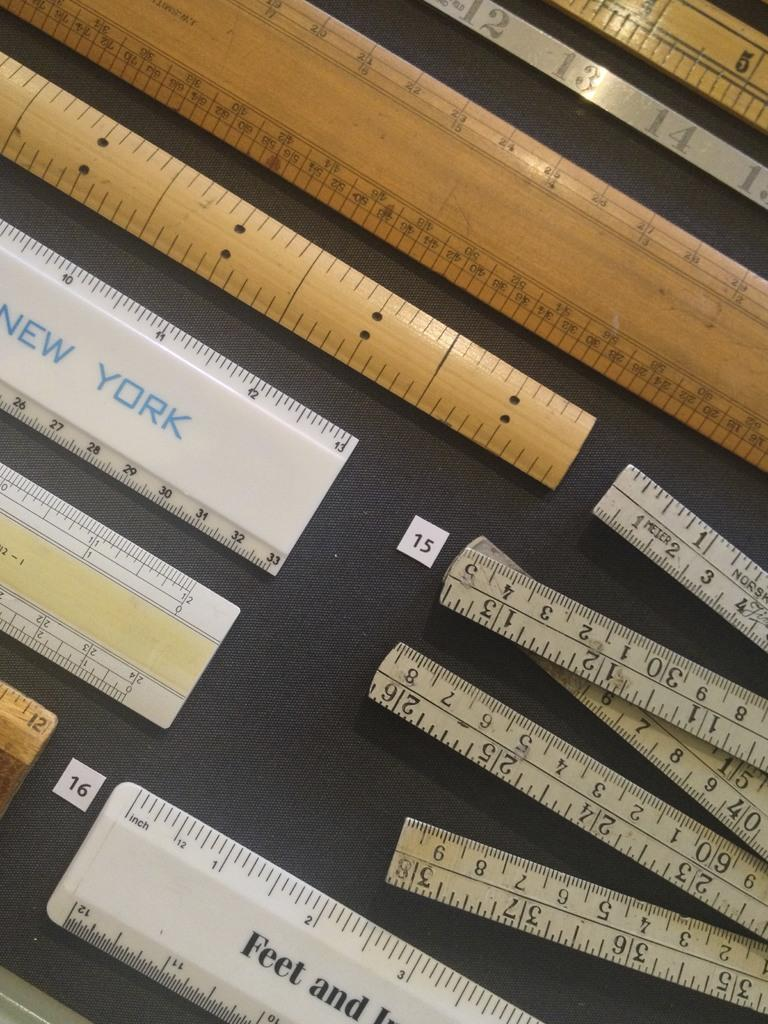<image>
Share a concise interpretation of the image provided. Rulers next to one another with one that says New York in blue. 